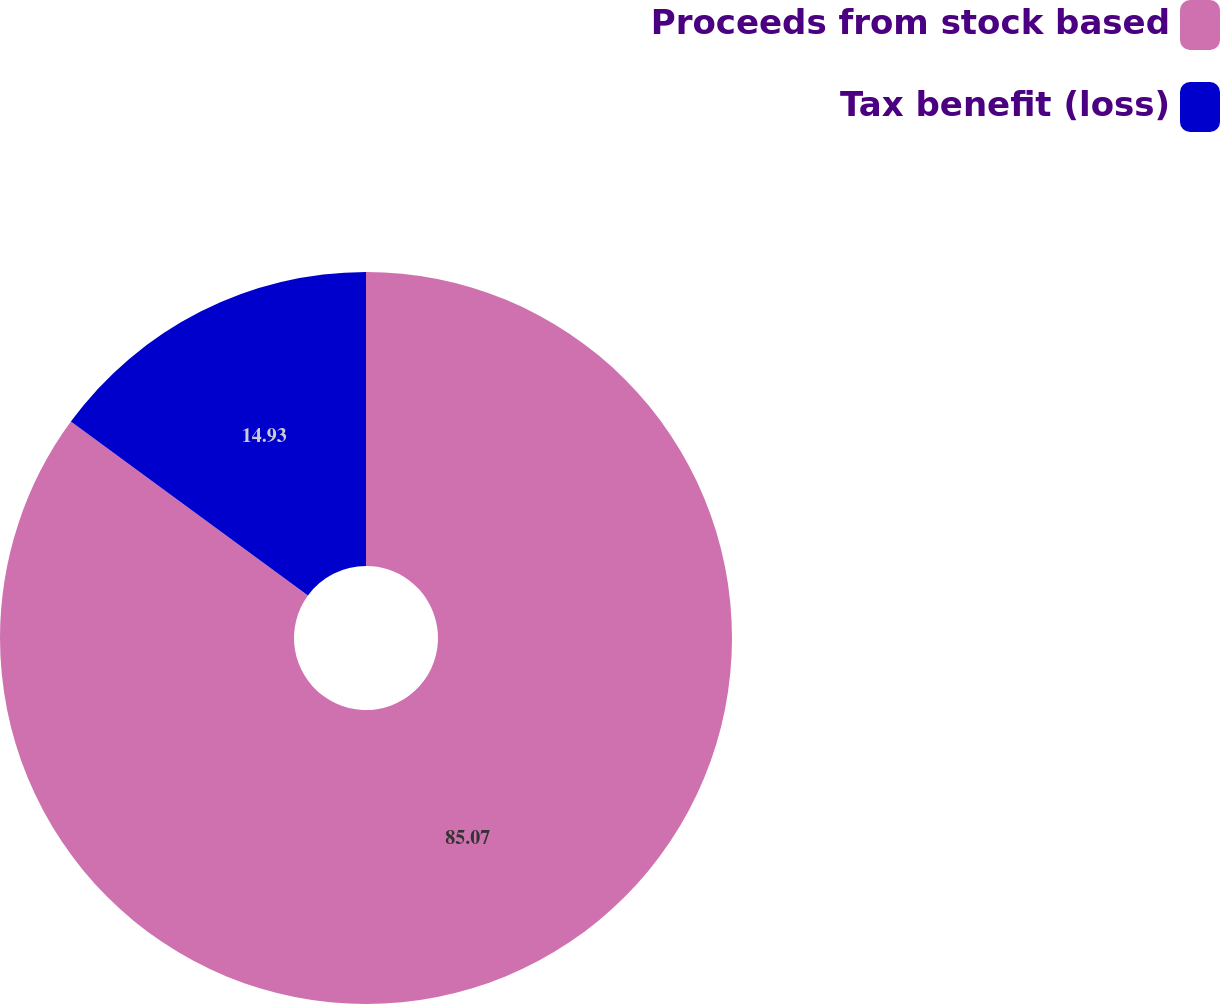<chart> <loc_0><loc_0><loc_500><loc_500><pie_chart><fcel>Proceeds from stock based<fcel>Tax benefit (loss)<nl><fcel>85.07%<fcel>14.93%<nl></chart> 